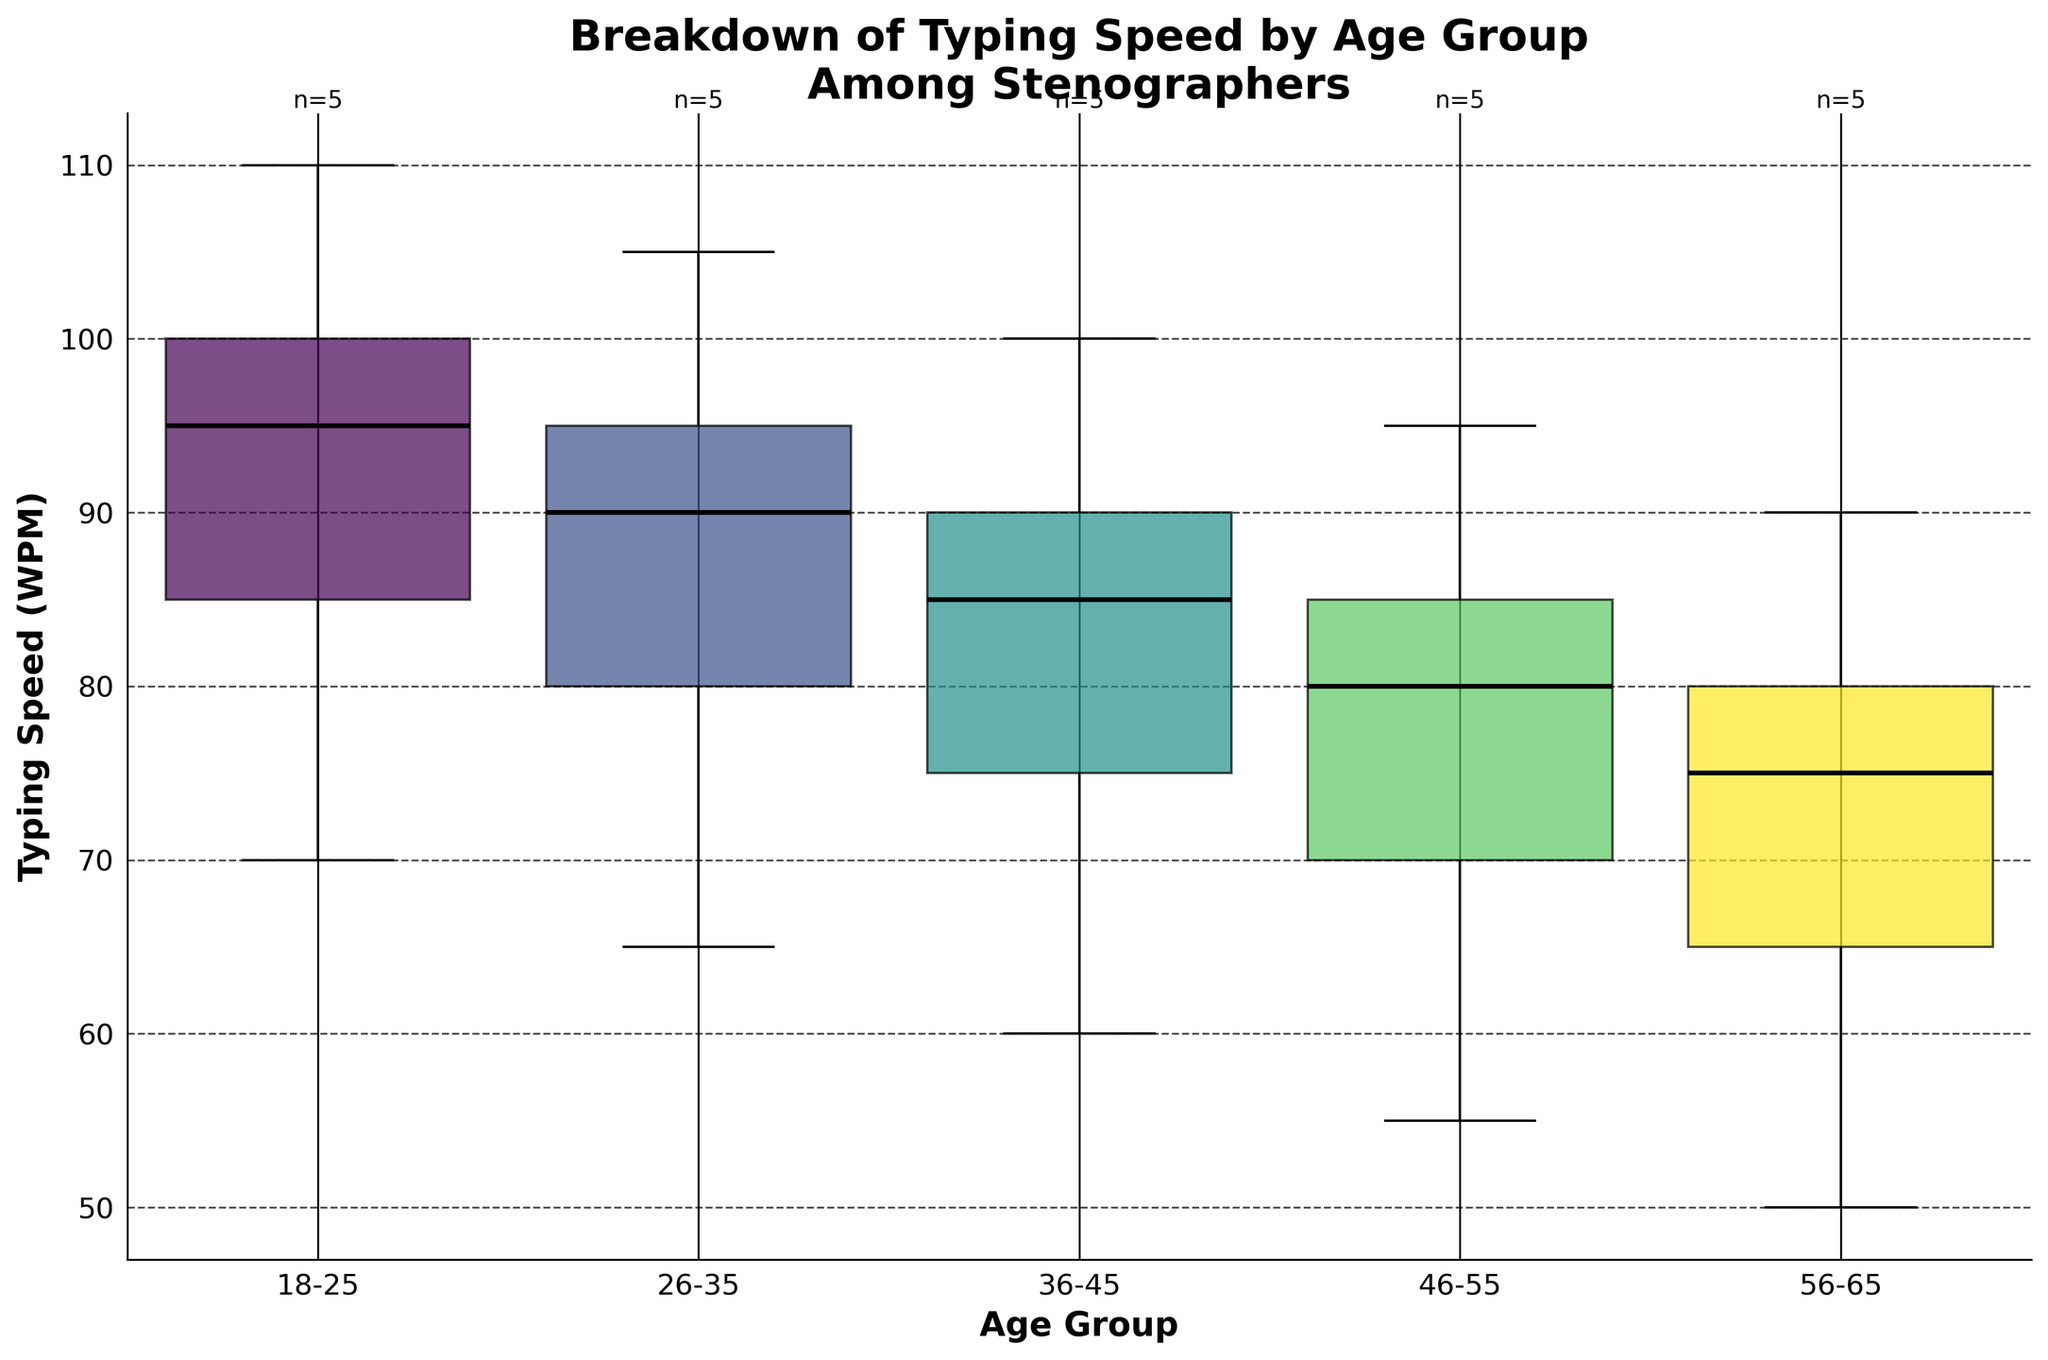What is the title of the figure? The title is often found at the top of the figure, summarizing what the plot is about. In this case, the title is "Breakdown of Typing Speed by Age Group Among Stenographers."
Answer: Breakdown of Typing Speed by Age Group Among Stenographers How many age groups are represented in the plot? Count the number of distinct box plots along the x-axis; each box plot represents a different age group.
Answer: Five Which age group shows the highest median typing speed? Look at the horizontal line in the middle of each box plot, which denotes the median value. The age group with the highest median line indicates the highest median typing speed.
Answer: 18-25 Which age group has the smallest variability in typing speed? Examine the width of the boxes (interquartile range) and whiskers (range) for each age group. The group with the narrowest box and shortest whiskers has the smallest variability.
Answer: 56-65 What is the approximate median typing speed for the 26-35 age group? Locate the median line inside the box for the 26-35 age group and check the corresponding value on the y-axis.
Answer: 90 WPM Which age group has the widest box, indicating the highest interquartile range? Look for the box with the largest vertical height, which indicates the highest interquartile range.
Answer: 36-45 For the age group 46-55, how does the median typing speed compare to the median typing speed of the age group 36-45? Compare the median lines (horizontal lines inside the boxes) of both age groups. If one line is higher than the other on the y-axis, it has a higher median typing speed.
Answer: Lower How many data points are there for the age group 18-25? Check the number written above the box plot for the 18-25 age group, which indicates the number of data points (n) in that group.
Answer: Five What is the main influence of daily practice hours on typing speed across different age groups observed in this plot? By comparing how the distributions and medians (central tendencies) change across different age groups, we can infer if daily practice hours consistently increase typing speed across the board.
Answer: Increases typing speed 